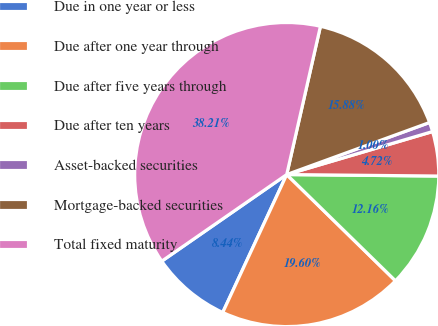Convert chart to OTSL. <chart><loc_0><loc_0><loc_500><loc_500><pie_chart><fcel>Due in one year or less<fcel>Due after one year through<fcel>Due after five years through<fcel>Due after ten years<fcel>Asset-backed securities<fcel>Mortgage-backed securities<fcel>Total fixed maturity<nl><fcel>8.44%<fcel>19.6%<fcel>12.16%<fcel>4.72%<fcel>1.0%<fcel>15.88%<fcel>38.21%<nl></chart> 